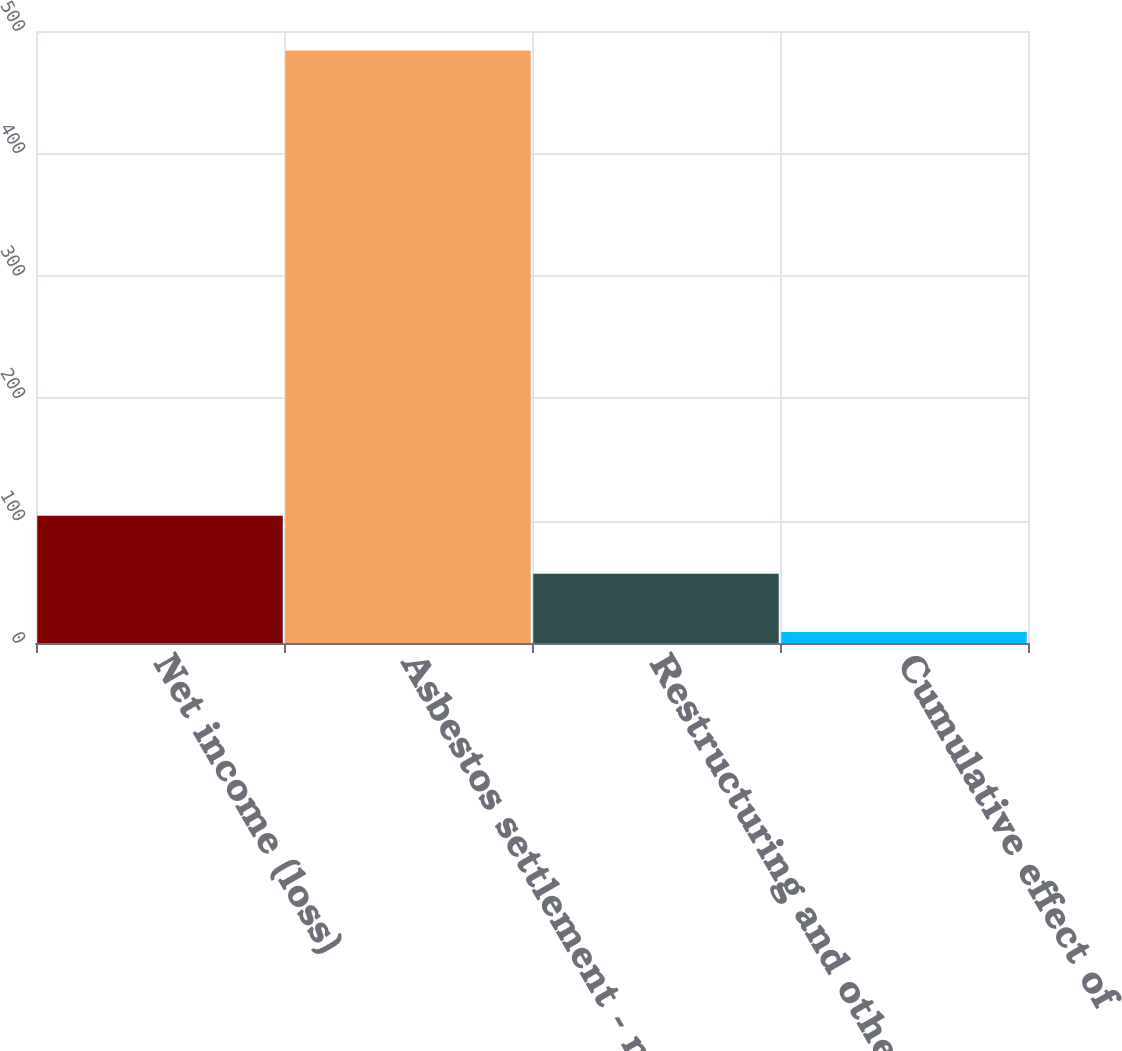<chart> <loc_0><loc_0><loc_500><loc_500><bar_chart><fcel>Net income (loss)<fcel>Asbestos settlement - net (See<fcel>Restructuring and other<fcel>Cumulative effect of<nl><fcel>104<fcel>484<fcel>56.5<fcel>9<nl></chart> 